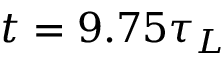<formula> <loc_0><loc_0><loc_500><loc_500>t = 9 . 7 5 \tau _ { L }</formula> 